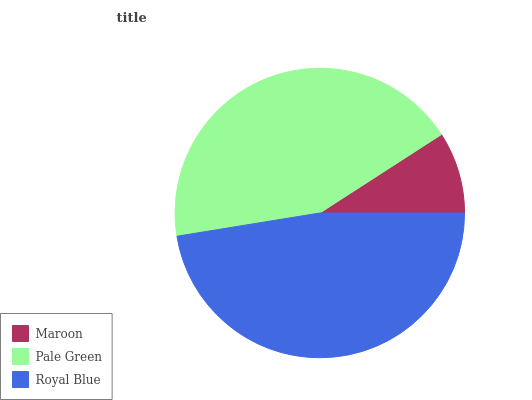Is Maroon the minimum?
Answer yes or no. Yes. Is Royal Blue the maximum?
Answer yes or no. Yes. Is Pale Green the minimum?
Answer yes or no. No. Is Pale Green the maximum?
Answer yes or no. No. Is Pale Green greater than Maroon?
Answer yes or no. Yes. Is Maroon less than Pale Green?
Answer yes or no. Yes. Is Maroon greater than Pale Green?
Answer yes or no. No. Is Pale Green less than Maroon?
Answer yes or no. No. Is Pale Green the high median?
Answer yes or no. Yes. Is Pale Green the low median?
Answer yes or no. Yes. Is Maroon the high median?
Answer yes or no. No. Is Royal Blue the low median?
Answer yes or no. No. 